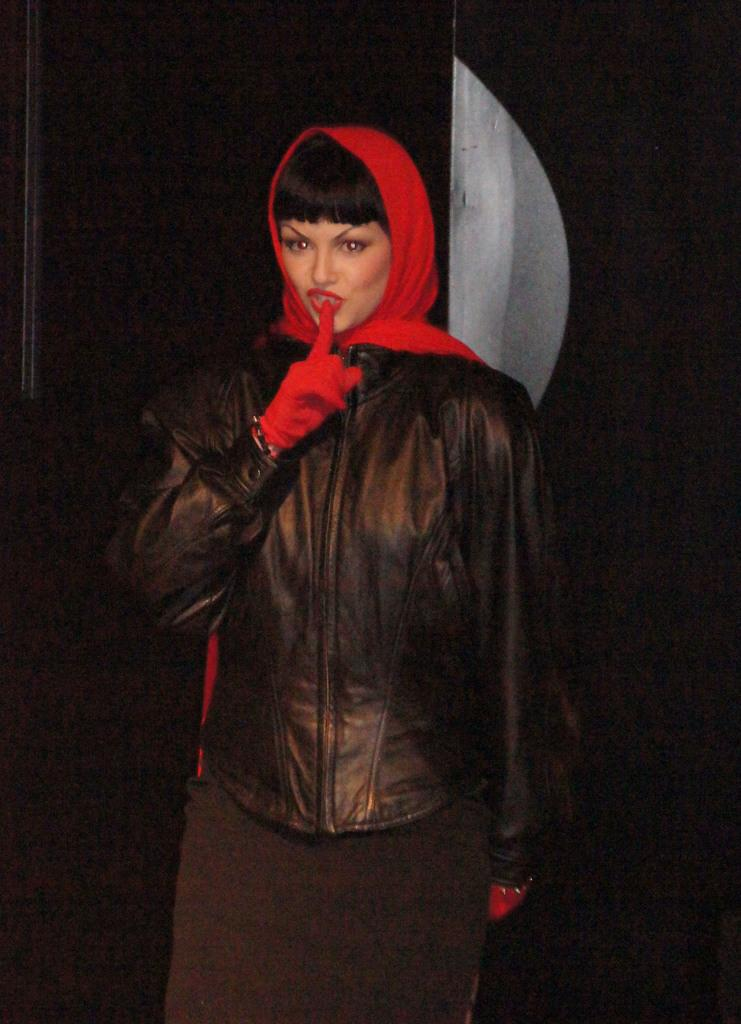Who is the main subject in the image? There is a woman in the image. What is the woman doing in the image? The woman is standing. What type of clothing is the woman wearing on her hands? The woman is wearing gloves. What color is the jacket the woman is wearing? The woman is wearing a black jacket. What can be observed about the background of the image? The background of the image is dark. What type of rhythm can be heard coming from the woman's gloves in the image? There is no indication in the image that the woman's gloves are producing any rhythm, as gloves do not typically make sounds. 